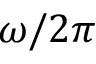Convert formula to latex. <formula><loc_0><loc_0><loc_500><loc_500>\omega / 2 \pi</formula> 